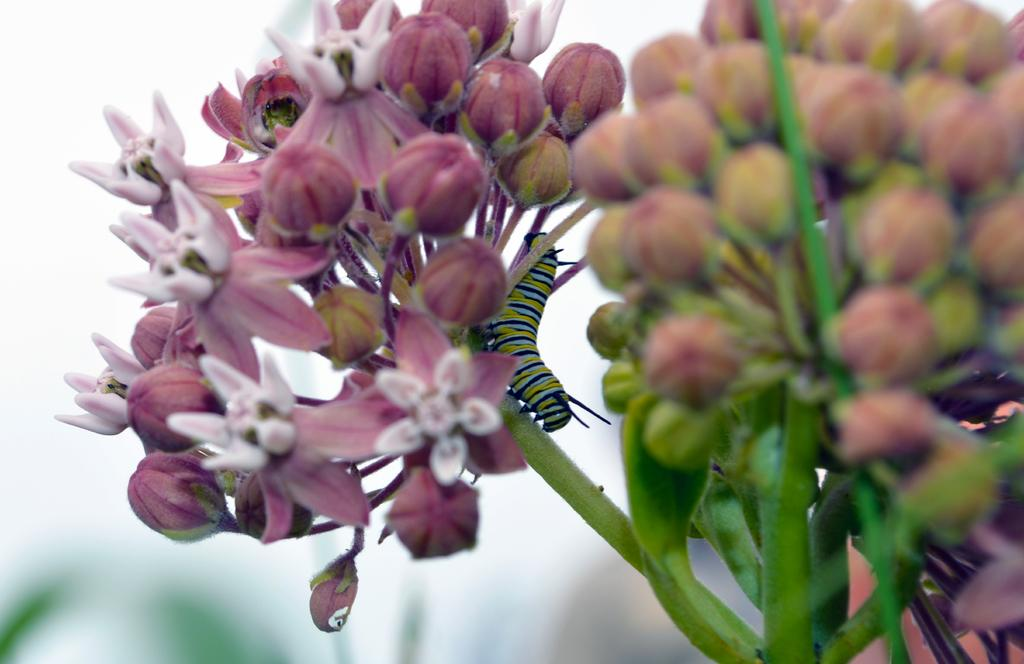What type of living organism can be seen in the image? There is an insect in the image. What type of plants are in the image? There are flowers and flower buds in the image. Can you describe the background of the image? The background of the image is blurry. What type of book is the insect reading in the image? There is no book present in the image; it features an insect and flowers. 